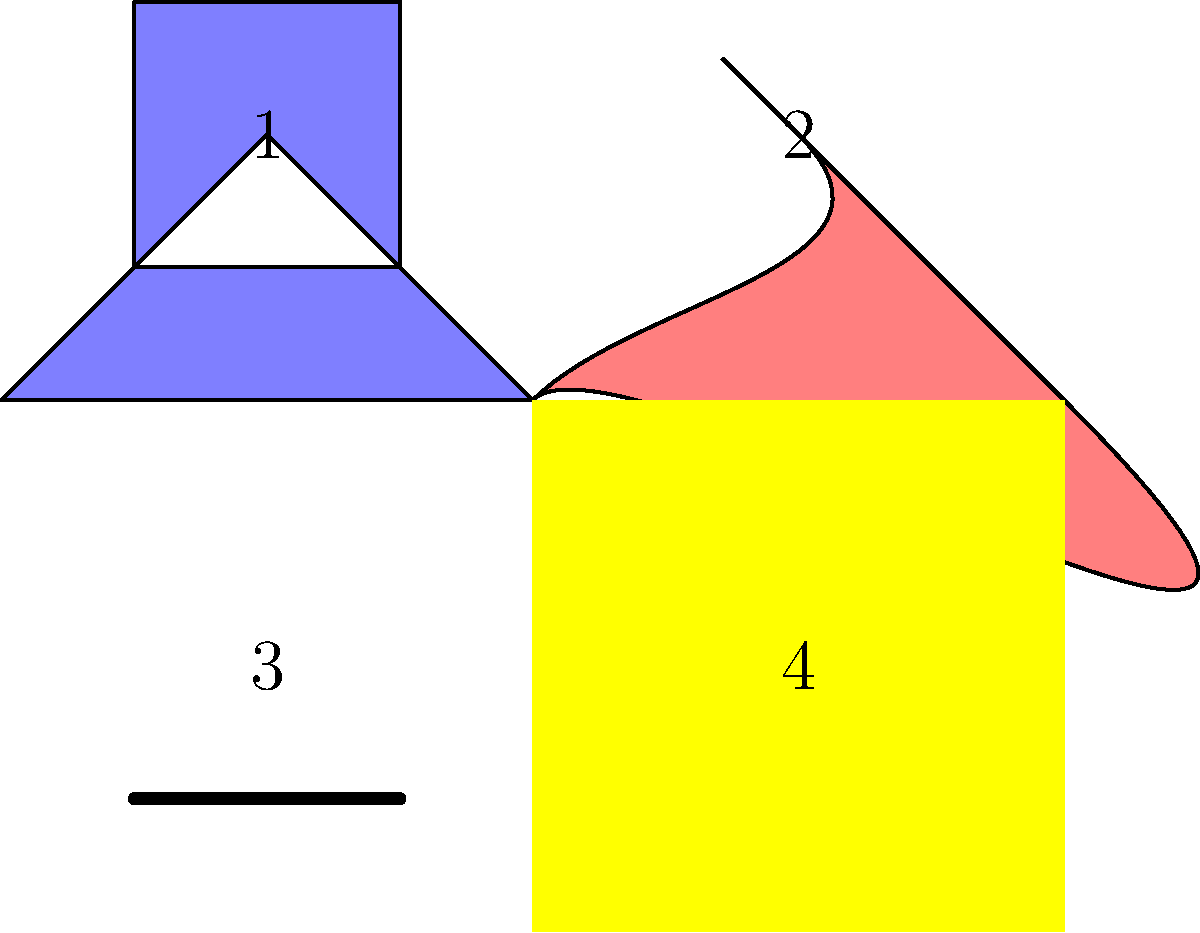As a curator aiming to attract a younger demographic, you're organizing an exhibition on different abstract art styles. Based on the sample images provided, which style would you classify as "Color Field" painting, known for its large areas of flat, solid color? To answer this question, let's analyze each style presented in the image:

1. Style 1 (top left): This style features geometric shapes, including triangles and squares. It's characterized by clean lines and distinct shapes, which is typical of Geometric Abstraction.

2. Style 2 (top right): This style shows curved, expressive lines that create a more organic shape. This is reminiscent of Abstract Expressionism, which often features gestural brushstrokes and emotional, non-representational forms.

3. Style 3 (bottom left): This style is represented by a single horizontal line. Its simplicity and reduction to essential elements are hallmarks of Minimalism in abstract art.

4. Style 4 (bottom right): This style is depicted as a solid block of color with no visible brushstrokes or additional elements. This aligns perfectly with the characteristics of Color Field painting.

Color Field painting, developed in the 1940s and 1950s, is characterized by large areas of flat, solid color spread across or stained into the canvas. It emphasizes the overall consistency of form and process. The style aims to create a meditative or immersive effect through its simplicity and the use of color as the main subject of the painting.

Among the four styles presented, Style 4 (bottom right) is the only one that exhibits these characteristics of Color Field painting. It presents a single, uniform area of color without any additional forms or lines, making it the correct answer to this question.
Answer: Style 4 